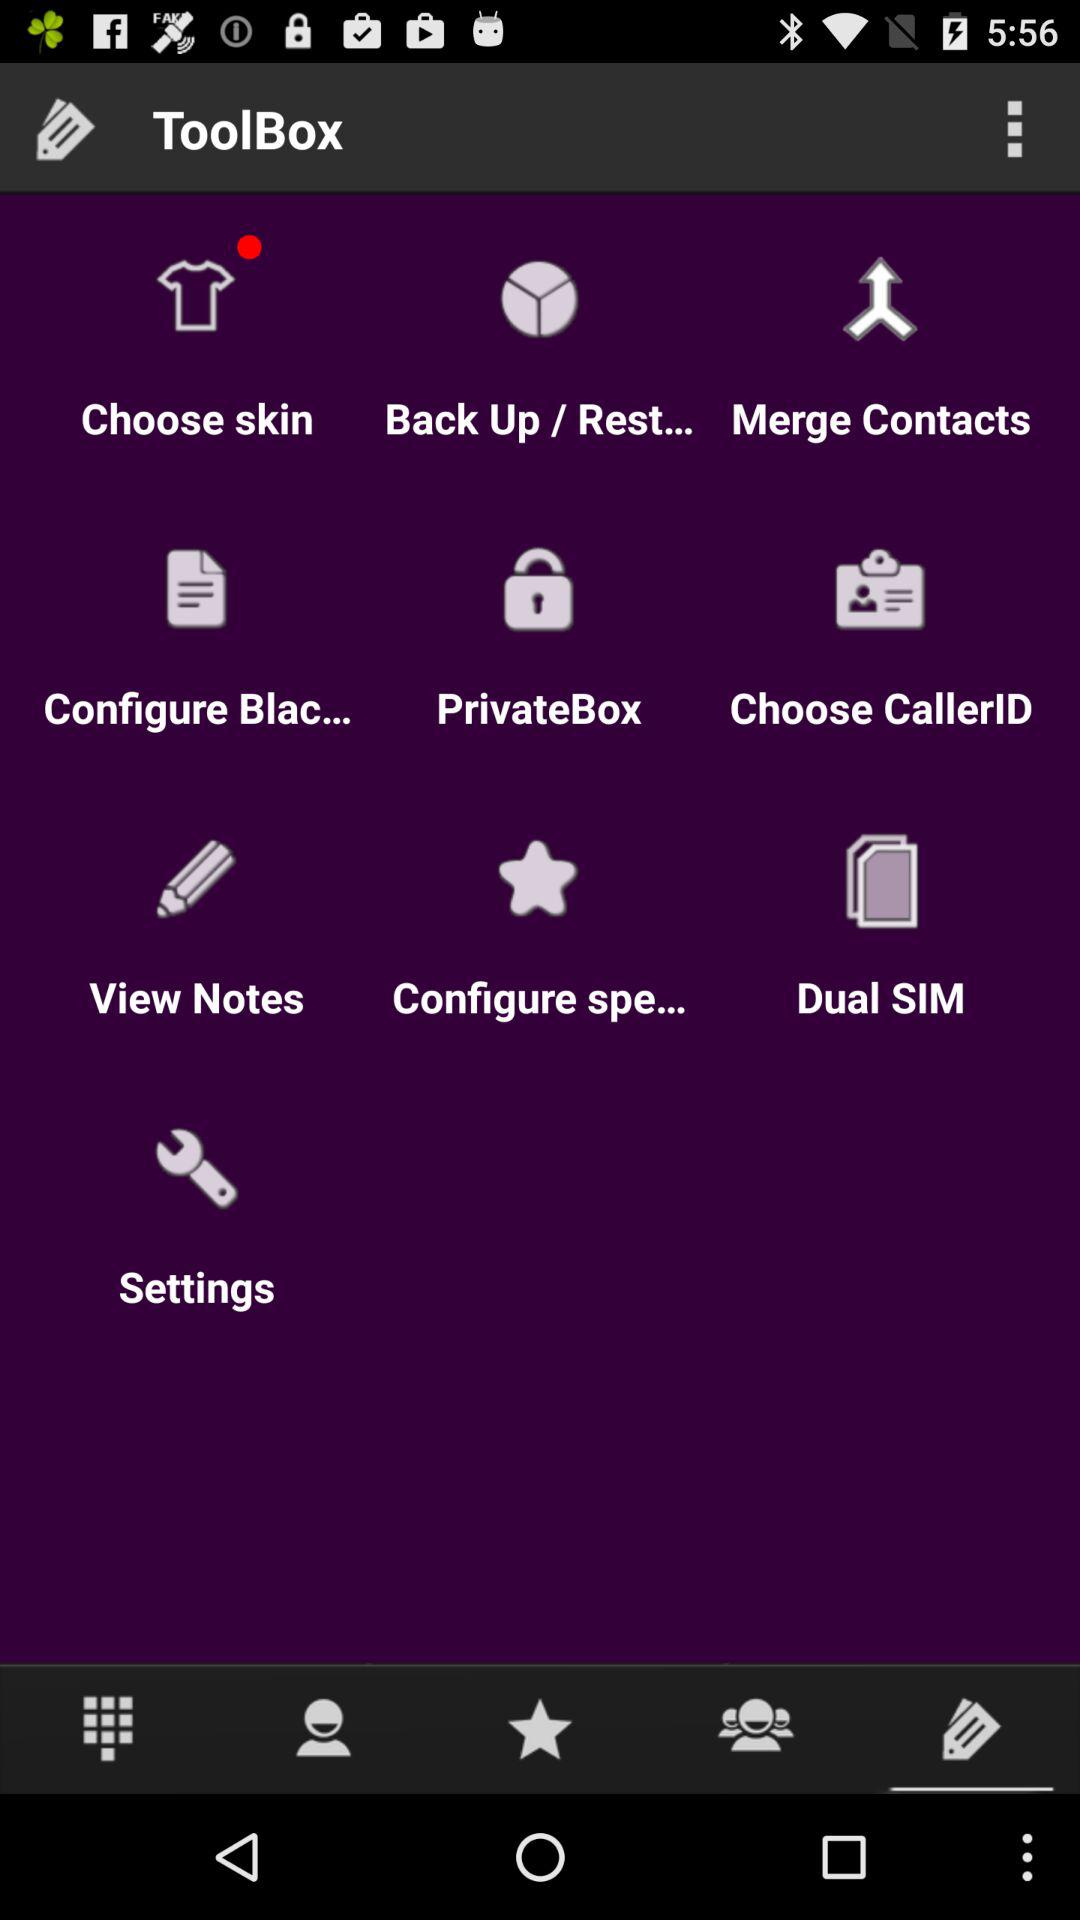Which tab is selected? The selected tab is "ToolBox". 